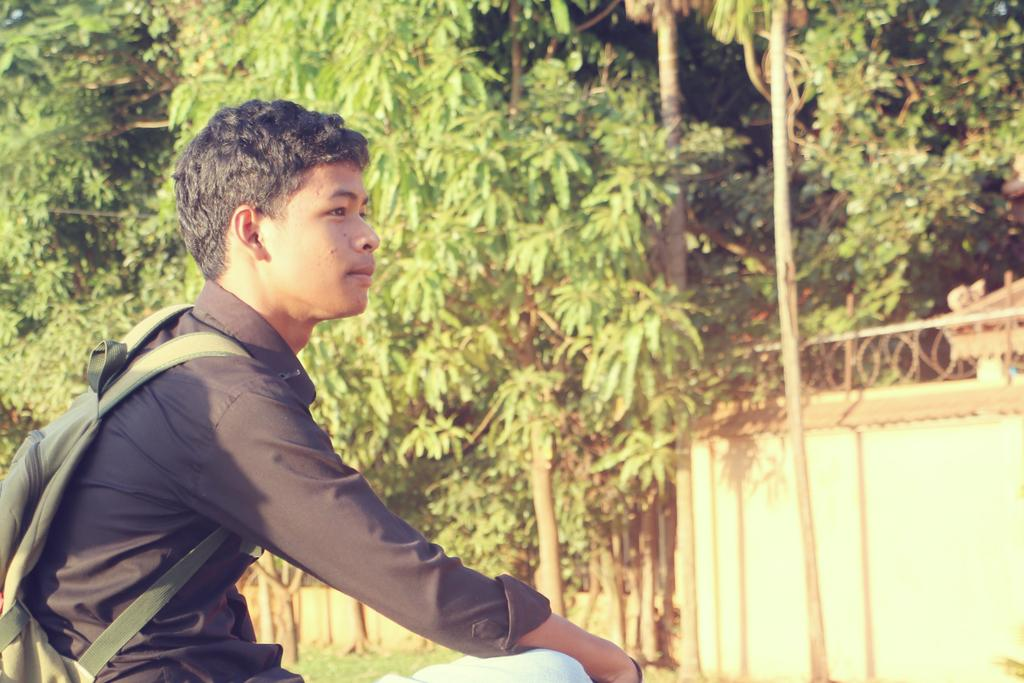What is the person in the image doing? There is a guy sitting in the image. What is the guy wearing? The guy is wearing a black shirt. What is the guy carrying in the image? The guy is carrying a bag. What can be seen in the background of the image? There are trees and a boundary visible in the background of the image. What type of pest can be seen crawling on the guy's shirt in the image? There is no pest visible on the guy's shirt in the image. What is the end result of the guy's actions in the image? The image does not depict any actions or events that have a specific end result. 